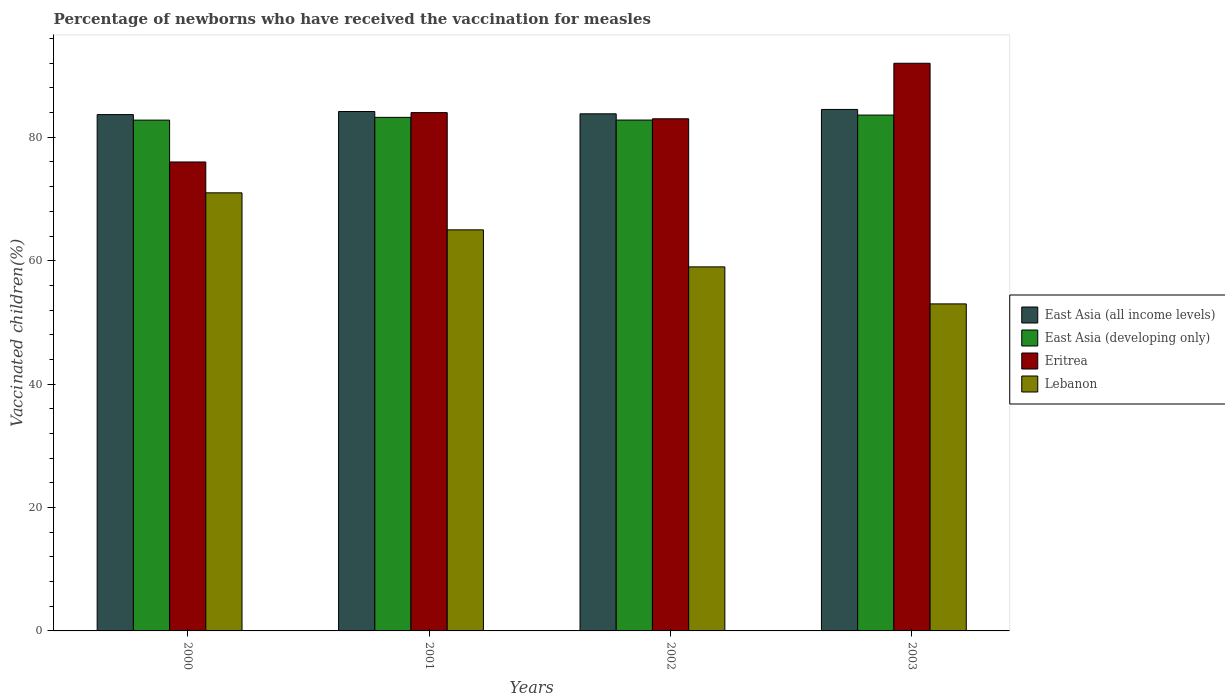How many different coloured bars are there?
Your answer should be compact. 4. Are the number of bars per tick equal to the number of legend labels?
Your answer should be very brief. Yes. Are the number of bars on each tick of the X-axis equal?
Provide a succinct answer. Yes. How many bars are there on the 1st tick from the left?
Offer a very short reply. 4. What is the label of the 3rd group of bars from the left?
Ensure brevity in your answer.  2002. In how many cases, is the number of bars for a given year not equal to the number of legend labels?
Offer a very short reply. 0. What is the percentage of vaccinated children in Eritrea in 2000?
Offer a very short reply. 76. Across all years, what is the maximum percentage of vaccinated children in Eritrea?
Your answer should be very brief. 92. Across all years, what is the minimum percentage of vaccinated children in Eritrea?
Give a very brief answer. 76. In which year was the percentage of vaccinated children in Lebanon maximum?
Ensure brevity in your answer.  2000. In which year was the percentage of vaccinated children in East Asia (all income levels) minimum?
Offer a very short reply. 2000. What is the total percentage of vaccinated children in East Asia (all income levels) in the graph?
Make the answer very short. 336.18. What is the difference between the percentage of vaccinated children in East Asia (developing only) in 2003 and the percentage of vaccinated children in East Asia (all income levels) in 2002?
Your answer should be very brief. -0.2. In the year 2002, what is the difference between the percentage of vaccinated children in Lebanon and percentage of vaccinated children in East Asia (developing only)?
Provide a succinct answer. -23.8. What is the ratio of the percentage of vaccinated children in East Asia (all income levels) in 2000 to that in 2001?
Make the answer very short. 0.99. What is the difference between the highest and the second highest percentage of vaccinated children in Eritrea?
Your answer should be compact. 8. What is the difference between the highest and the lowest percentage of vaccinated children in East Asia (all income levels)?
Keep it short and to the point. 0.83. In how many years, is the percentage of vaccinated children in East Asia (developing only) greater than the average percentage of vaccinated children in East Asia (developing only) taken over all years?
Your answer should be very brief. 2. Is the sum of the percentage of vaccinated children in East Asia (developing only) in 2000 and 2002 greater than the maximum percentage of vaccinated children in East Asia (all income levels) across all years?
Your answer should be very brief. Yes. Is it the case that in every year, the sum of the percentage of vaccinated children in Lebanon and percentage of vaccinated children in Eritrea is greater than the sum of percentage of vaccinated children in East Asia (developing only) and percentage of vaccinated children in East Asia (all income levels)?
Offer a terse response. No. What does the 1st bar from the left in 2000 represents?
Keep it short and to the point. East Asia (all income levels). What does the 4th bar from the right in 2001 represents?
Give a very brief answer. East Asia (all income levels). Is it the case that in every year, the sum of the percentage of vaccinated children in Lebanon and percentage of vaccinated children in East Asia (all income levels) is greater than the percentage of vaccinated children in East Asia (developing only)?
Offer a very short reply. Yes. How many bars are there?
Give a very brief answer. 16. How many years are there in the graph?
Your answer should be compact. 4. Does the graph contain any zero values?
Keep it short and to the point. No. Does the graph contain grids?
Your response must be concise. No. Where does the legend appear in the graph?
Keep it short and to the point. Center right. How are the legend labels stacked?
Your answer should be very brief. Vertical. What is the title of the graph?
Provide a short and direct response. Percentage of newborns who have received the vaccination for measles. Does "France" appear as one of the legend labels in the graph?
Provide a succinct answer. No. What is the label or title of the X-axis?
Ensure brevity in your answer.  Years. What is the label or title of the Y-axis?
Ensure brevity in your answer.  Vaccinated children(%). What is the Vaccinated children(%) in East Asia (all income levels) in 2000?
Your response must be concise. 83.68. What is the Vaccinated children(%) of East Asia (developing only) in 2000?
Provide a succinct answer. 82.79. What is the Vaccinated children(%) in Lebanon in 2000?
Give a very brief answer. 71. What is the Vaccinated children(%) of East Asia (all income levels) in 2001?
Your answer should be very brief. 84.18. What is the Vaccinated children(%) of East Asia (developing only) in 2001?
Your response must be concise. 83.23. What is the Vaccinated children(%) in Eritrea in 2001?
Make the answer very short. 84. What is the Vaccinated children(%) in East Asia (all income levels) in 2002?
Give a very brief answer. 83.81. What is the Vaccinated children(%) of East Asia (developing only) in 2002?
Offer a very short reply. 82.8. What is the Vaccinated children(%) in Eritrea in 2002?
Provide a succinct answer. 83. What is the Vaccinated children(%) of East Asia (all income levels) in 2003?
Give a very brief answer. 84.51. What is the Vaccinated children(%) in East Asia (developing only) in 2003?
Offer a very short reply. 83.6. What is the Vaccinated children(%) in Eritrea in 2003?
Give a very brief answer. 92. Across all years, what is the maximum Vaccinated children(%) in East Asia (all income levels)?
Keep it short and to the point. 84.51. Across all years, what is the maximum Vaccinated children(%) of East Asia (developing only)?
Your response must be concise. 83.6. Across all years, what is the maximum Vaccinated children(%) in Eritrea?
Your response must be concise. 92. Across all years, what is the minimum Vaccinated children(%) in East Asia (all income levels)?
Give a very brief answer. 83.68. Across all years, what is the minimum Vaccinated children(%) in East Asia (developing only)?
Your response must be concise. 82.79. Across all years, what is the minimum Vaccinated children(%) in Eritrea?
Offer a very short reply. 76. What is the total Vaccinated children(%) in East Asia (all income levels) in the graph?
Provide a succinct answer. 336.18. What is the total Vaccinated children(%) in East Asia (developing only) in the graph?
Provide a succinct answer. 332.42. What is the total Vaccinated children(%) in Eritrea in the graph?
Give a very brief answer. 335. What is the total Vaccinated children(%) in Lebanon in the graph?
Provide a succinct answer. 248. What is the difference between the Vaccinated children(%) in East Asia (all income levels) in 2000 and that in 2001?
Ensure brevity in your answer.  -0.5. What is the difference between the Vaccinated children(%) in East Asia (developing only) in 2000 and that in 2001?
Keep it short and to the point. -0.44. What is the difference between the Vaccinated children(%) of Eritrea in 2000 and that in 2001?
Your response must be concise. -8. What is the difference between the Vaccinated children(%) of East Asia (all income levels) in 2000 and that in 2002?
Offer a terse response. -0.13. What is the difference between the Vaccinated children(%) of East Asia (developing only) in 2000 and that in 2002?
Make the answer very short. -0.01. What is the difference between the Vaccinated children(%) in Lebanon in 2000 and that in 2002?
Provide a short and direct response. 12. What is the difference between the Vaccinated children(%) of East Asia (all income levels) in 2000 and that in 2003?
Your answer should be very brief. -0.83. What is the difference between the Vaccinated children(%) of East Asia (developing only) in 2000 and that in 2003?
Your answer should be very brief. -0.82. What is the difference between the Vaccinated children(%) of Eritrea in 2000 and that in 2003?
Your answer should be compact. -16. What is the difference between the Vaccinated children(%) in East Asia (all income levels) in 2001 and that in 2002?
Give a very brief answer. 0.37. What is the difference between the Vaccinated children(%) in East Asia (developing only) in 2001 and that in 2002?
Provide a succinct answer. 0.43. What is the difference between the Vaccinated children(%) in Eritrea in 2001 and that in 2002?
Provide a short and direct response. 1. What is the difference between the Vaccinated children(%) of Lebanon in 2001 and that in 2002?
Give a very brief answer. 6. What is the difference between the Vaccinated children(%) in East Asia (all income levels) in 2001 and that in 2003?
Make the answer very short. -0.33. What is the difference between the Vaccinated children(%) of East Asia (developing only) in 2001 and that in 2003?
Provide a short and direct response. -0.37. What is the difference between the Vaccinated children(%) of Lebanon in 2001 and that in 2003?
Offer a very short reply. 12. What is the difference between the Vaccinated children(%) of East Asia (all income levels) in 2002 and that in 2003?
Keep it short and to the point. -0.71. What is the difference between the Vaccinated children(%) in East Asia (developing only) in 2002 and that in 2003?
Offer a terse response. -0.81. What is the difference between the Vaccinated children(%) in Lebanon in 2002 and that in 2003?
Keep it short and to the point. 6. What is the difference between the Vaccinated children(%) in East Asia (all income levels) in 2000 and the Vaccinated children(%) in East Asia (developing only) in 2001?
Provide a succinct answer. 0.45. What is the difference between the Vaccinated children(%) in East Asia (all income levels) in 2000 and the Vaccinated children(%) in Eritrea in 2001?
Give a very brief answer. -0.32. What is the difference between the Vaccinated children(%) of East Asia (all income levels) in 2000 and the Vaccinated children(%) of Lebanon in 2001?
Provide a succinct answer. 18.68. What is the difference between the Vaccinated children(%) in East Asia (developing only) in 2000 and the Vaccinated children(%) in Eritrea in 2001?
Give a very brief answer. -1.21. What is the difference between the Vaccinated children(%) of East Asia (developing only) in 2000 and the Vaccinated children(%) of Lebanon in 2001?
Give a very brief answer. 17.79. What is the difference between the Vaccinated children(%) in East Asia (all income levels) in 2000 and the Vaccinated children(%) in East Asia (developing only) in 2002?
Provide a short and direct response. 0.88. What is the difference between the Vaccinated children(%) in East Asia (all income levels) in 2000 and the Vaccinated children(%) in Eritrea in 2002?
Your response must be concise. 0.68. What is the difference between the Vaccinated children(%) in East Asia (all income levels) in 2000 and the Vaccinated children(%) in Lebanon in 2002?
Your answer should be very brief. 24.68. What is the difference between the Vaccinated children(%) in East Asia (developing only) in 2000 and the Vaccinated children(%) in Eritrea in 2002?
Keep it short and to the point. -0.21. What is the difference between the Vaccinated children(%) of East Asia (developing only) in 2000 and the Vaccinated children(%) of Lebanon in 2002?
Provide a short and direct response. 23.79. What is the difference between the Vaccinated children(%) in Eritrea in 2000 and the Vaccinated children(%) in Lebanon in 2002?
Your answer should be very brief. 17. What is the difference between the Vaccinated children(%) in East Asia (all income levels) in 2000 and the Vaccinated children(%) in East Asia (developing only) in 2003?
Ensure brevity in your answer.  0.08. What is the difference between the Vaccinated children(%) of East Asia (all income levels) in 2000 and the Vaccinated children(%) of Eritrea in 2003?
Make the answer very short. -8.32. What is the difference between the Vaccinated children(%) in East Asia (all income levels) in 2000 and the Vaccinated children(%) in Lebanon in 2003?
Ensure brevity in your answer.  30.68. What is the difference between the Vaccinated children(%) of East Asia (developing only) in 2000 and the Vaccinated children(%) of Eritrea in 2003?
Give a very brief answer. -9.21. What is the difference between the Vaccinated children(%) of East Asia (developing only) in 2000 and the Vaccinated children(%) of Lebanon in 2003?
Provide a short and direct response. 29.79. What is the difference between the Vaccinated children(%) of East Asia (all income levels) in 2001 and the Vaccinated children(%) of East Asia (developing only) in 2002?
Your answer should be compact. 1.38. What is the difference between the Vaccinated children(%) of East Asia (all income levels) in 2001 and the Vaccinated children(%) of Eritrea in 2002?
Ensure brevity in your answer.  1.18. What is the difference between the Vaccinated children(%) of East Asia (all income levels) in 2001 and the Vaccinated children(%) of Lebanon in 2002?
Keep it short and to the point. 25.18. What is the difference between the Vaccinated children(%) of East Asia (developing only) in 2001 and the Vaccinated children(%) of Eritrea in 2002?
Give a very brief answer. 0.23. What is the difference between the Vaccinated children(%) in East Asia (developing only) in 2001 and the Vaccinated children(%) in Lebanon in 2002?
Offer a very short reply. 24.23. What is the difference between the Vaccinated children(%) in Eritrea in 2001 and the Vaccinated children(%) in Lebanon in 2002?
Provide a short and direct response. 25. What is the difference between the Vaccinated children(%) in East Asia (all income levels) in 2001 and the Vaccinated children(%) in East Asia (developing only) in 2003?
Keep it short and to the point. 0.58. What is the difference between the Vaccinated children(%) in East Asia (all income levels) in 2001 and the Vaccinated children(%) in Eritrea in 2003?
Offer a terse response. -7.82. What is the difference between the Vaccinated children(%) of East Asia (all income levels) in 2001 and the Vaccinated children(%) of Lebanon in 2003?
Provide a succinct answer. 31.18. What is the difference between the Vaccinated children(%) in East Asia (developing only) in 2001 and the Vaccinated children(%) in Eritrea in 2003?
Provide a short and direct response. -8.77. What is the difference between the Vaccinated children(%) of East Asia (developing only) in 2001 and the Vaccinated children(%) of Lebanon in 2003?
Offer a very short reply. 30.23. What is the difference between the Vaccinated children(%) in East Asia (all income levels) in 2002 and the Vaccinated children(%) in East Asia (developing only) in 2003?
Make the answer very short. 0.2. What is the difference between the Vaccinated children(%) of East Asia (all income levels) in 2002 and the Vaccinated children(%) of Eritrea in 2003?
Make the answer very short. -8.19. What is the difference between the Vaccinated children(%) in East Asia (all income levels) in 2002 and the Vaccinated children(%) in Lebanon in 2003?
Your response must be concise. 30.81. What is the difference between the Vaccinated children(%) in East Asia (developing only) in 2002 and the Vaccinated children(%) in Eritrea in 2003?
Provide a succinct answer. -9.2. What is the difference between the Vaccinated children(%) in East Asia (developing only) in 2002 and the Vaccinated children(%) in Lebanon in 2003?
Ensure brevity in your answer.  29.8. What is the difference between the Vaccinated children(%) in Eritrea in 2002 and the Vaccinated children(%) in Lebanon in 2003?
Your answer should be very brief. 30. What is the average Vaccinated children(%) in East Asia (all income levels) per year?
Your answer should be compact. 84.04. What is the average Vaccinated children(%) of East Asia (developing only) per year?
Ensure brevity in your answer.  83.1. What is the average Vaccinated children(%) of Eritrea per year?
Keep it short and to the point. 83.75. In the year 2000, what is the difference between the Vaccinated children(%) in East Asia (all income levels) and Vaccinated children(%) in East Asia (developing only)?
Provide a succinct answer. 0.89. In the year 2000, what is the difference between the Vaccinated children(%) in East Asia (all income levels) and Vaccinated children(%) in Eritrea?
Provide a short and direct response. 7.68. In the year 2000, what is the difference between the Vaccinated children(%) in East Asia (all income levels) and Vaccinated children(%) in Lebanon?
Provide a succinct answer. 12.68. In the year 2000, what is the difference between the Vaccinated children(%) of East Asia (developing only) and Vaccinated children(%) of Eritrea?
Keep it short and to the point. 6.79. In the year 2000, what is the difference between the Vaccinated children(%) of East Asia (developing only) and Vaccinated children(%) of Lebanon?
Make the answer very short. 11.79. In the year 2000, what is the difference between the Vaccinated children(%) in Eritrea and Vaccinated children(%) in Lebanon?
Your answer should be compact. 5. In the year 2001, what is the difference between the Vaccinated children(%) of East Asia (all income levels) and Vaccinated children(%) of East Asia (developing only)?
Provide a short and direct response. 0.95. In the year 2001, what is the difference between the Vaccinated children(%) of East Asia (all income levels) and Vaccinated children(%) of Eritrea?
Provide a succinct answer. 0.18. In the year 2001, what is the difference between the Vaccinated children(%) of East Asia (all income levels) and Vaccinated children(%) of Lebanon?
Keep it short and to the point. 19.18. In the year 2001, what is the difference between the Vaccinated children(%) in East Asia (developing only) and Vaccinated children(%) in Eritrea?
Make the answer very short. -0.77. In the year 2001, what is the difference between the Vaccinated children(%) in East Asia (developing only) and Vaccinated children(%) in Lebanon?
Your response must be concise. 18.23. In the year 2002, what is the difference between the Vaccinated children(%) in East Asia (all income levels) and Vaccinated children(%) in East Asia (developing only)?
Provide a succinct answer. 1.01. In the year 2002, what is the difference between the Vaccinated children(%) of East Asia (all income levels) and Vaccinated children(%) of Eritrea?
Ensure brevity in your answer.  0.81. In the year 2002, what is the difference between the Vaccinated children(%) of East Asia (all income levels) and Vaccinated children(%) of Lebanon?
Your answer should be very brief. 24.81. In the year 2002, what is the difference between the Vaccinated children(%) in East Asia (developing only) and Vaccinated children(%) in Eritrea?
Offer a very short reply. -0.2. In the year 2002, what is the difference between the Vaccinated children(%) in East Asia (developing only) and Vaccinated children(%) in Lebanon?
Make the answer very short. 23.8. In the year 2003, what is the difference between the Vaccinated children(%) in East Asia (all income levels) and Vaccinated children(%) in East Asia (developing only)?
Provide a short and direct response. 0.91. In the year 2003, what is the difference between the Vaccinated children(%) of East Asia (all income levels) and Vaccinated children(%) of Eritrea?
Provide a succinct answer. -7.49. In the year 2003, what is the difference between the Vaccinated children(%) in East Asia (all income levels) and Vaccinated children(%) in Lebanon?
Offer a terse response. 31.51. In the year 2003, what is the difference between the Vaccinated children(%) in East Asia (developing only) and Vaccinated children(%) in Eritrea?
Ensure brevity in your answer.  -8.4. In the year 2003, what is the difference between the Vaccinated children(%) in East Asia (developing only) and Vaccinated children(%) in Lebanon?
Ensure brevity in your answer.  30.6. What is the ratio of the Vaccinated children(%) of East Asia (all income levels) in 2000 to that in 2001?
Ensure brevity in your answer.  0.99. What is the ratio of the Vaccinated children(%) of Eritrea in 2000 to that in 2001?
Ensure brevity in your answer.  0.9. What is the ratio of the Vaccinated children(%) in Lebanon in 2000 to that in 2001?
Give a very brief answer. 1.09. What is the ratio of the Vaccinated children(%) of Eritrea in 2000 to that in 2002?
Your answer should be very brief. 0.92. What is the ratio of the Vaccinated children(%) in Lebanon in 2000 to that in 2002?
Offer a terse response. 1.2. What is the ratio of the Vaccinated children(%) of East Asia (developing only) in 2000 to that in 2003?
Your answer should be very brief. 0.99. What is the ratio of the Vaccinated children(%) in Eritrea in 2000 to that in 2003?
Keep it short and to the point. 0.83. What is the ratio of the Vaccinated children(%) in Lebanon in 2000 to that in 2003?
Keep it short and to the point. 1.34. What is the ratio of the Vaccinated children(%) of Lebanon in 2001 to that in 2002?
Offer a very short reply. 1.1. What is the ratio of the Vaccinated children(%) in East Asia (all income levels) in 2001 to that in 2003?
Your answer should be very brief. 1. What is the ratio of the Vaccinated children(%) of Eritrea in 2001 to that in 2003?
Your response must be concise. 0.91. What is the ratio of the Vaccinated children(%) in Lebanon in 2001 to that in 2003?
Provide a short and direct response. 1.23. What is the ratio of the Vaccinated children(%) of East Asia (all income levels) in 2002 to that in 2003?
Your answer should be compact. 0.99. What is the ratio of the Vaccinated children(%) of Eritrea in 2002 to that in 2003?
Your answer should be compact. 0.9. What is the ratio of the Vaccinated children(%) in Lebanon in 2002 to that in 2003?
Offer a very short reply. 1.11. What is the difference between the highest and the second highest Vaccinated children(%) in East Asia (all income levels)?
Make the answer very short. 0.33. What is the difference between the highest and the second highest Vaccinated children(%) of East Asia (developing only)?
Provide a succinct answer. 0.37. What is the difference between the highest and the second highest Vaccinated children(%) of Lebanon?
Provide a succinct answer. 6. What is the difference between the highest and the lowest Vaccinated children(%) in East Asia (all income levels)?
Ensure brevity in your answer.  0.83. What is the difference between the highest and the lowest Vaccinated children(%) of East Asia (developing only)?
Make the answer very short. 0.82. What is the difference between the highest and the lowest Vaccinated children(%) of Eritrea?
Your answer should be very brief. 16. What is the difference between the highest and the lowest Vaccinated children(%) of Lebanon?
Offer a terse response. 18. 